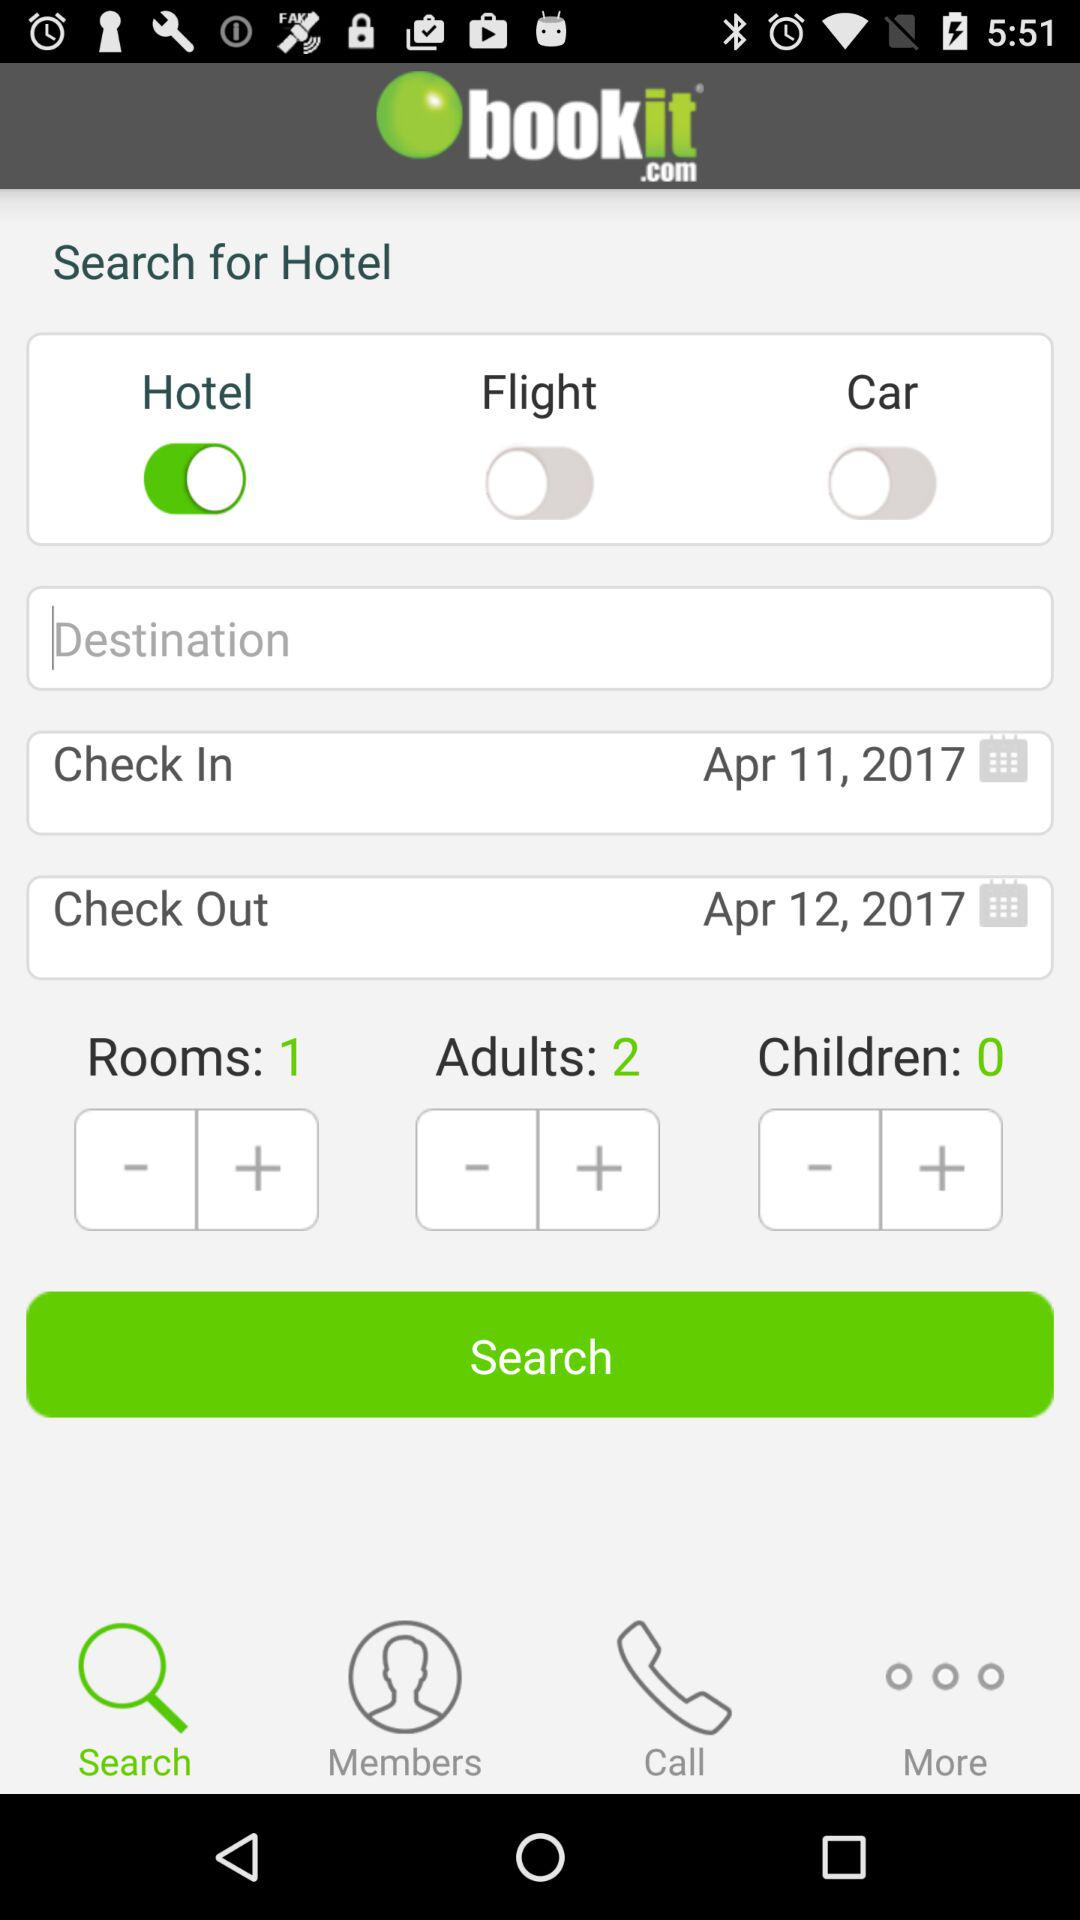What is the user searching for? The user is searching for a hotel. 